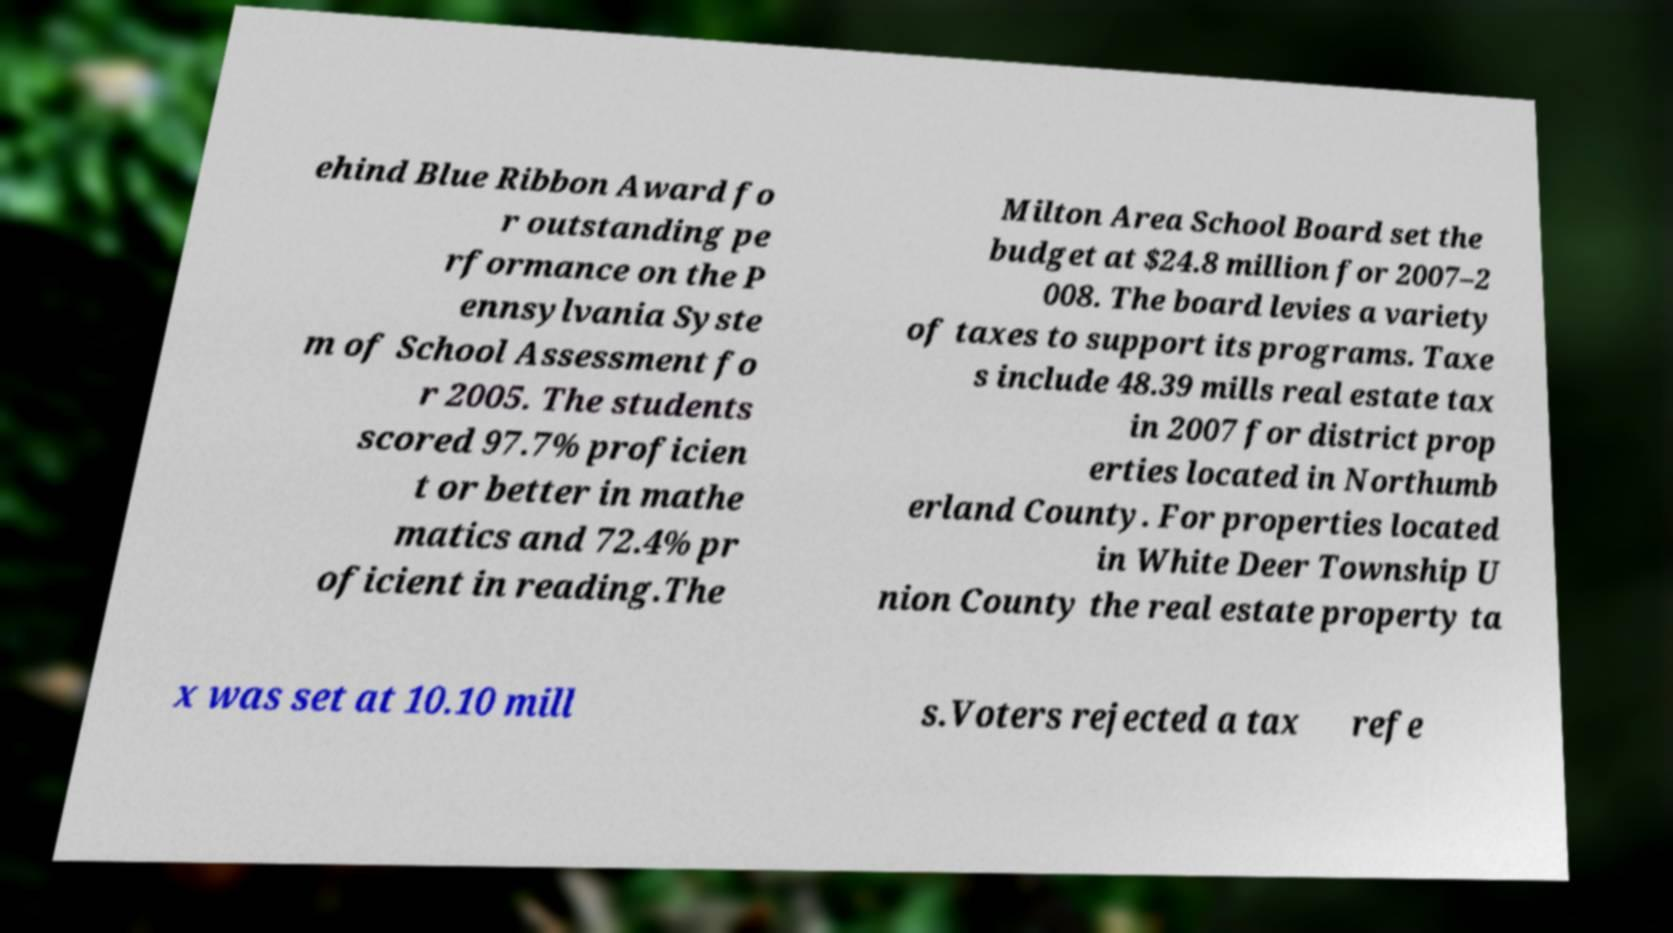Can you accurately transcribe the text from the provided image for me? ehind Blue Ribbon Award fo r outstanding pe rformance on the P ennsylvania Syste m of School Assessment fo r 2005. The students scored 97.7% proficien t or better in mathe matics and 72.4% pr oficient in reading.The Milton Area School Board set the budget at $24.8 million for 2007–2 008. The board levies a variety of taxes to support its programs. Taxe s include 48.39 mills real estate tax in 2007 for district prop erties located in Northumb erland County. For properties located in White Deer Township U nion County the real estate property ta x was set at 10.10 mill s.Voters rejected a tax refe 